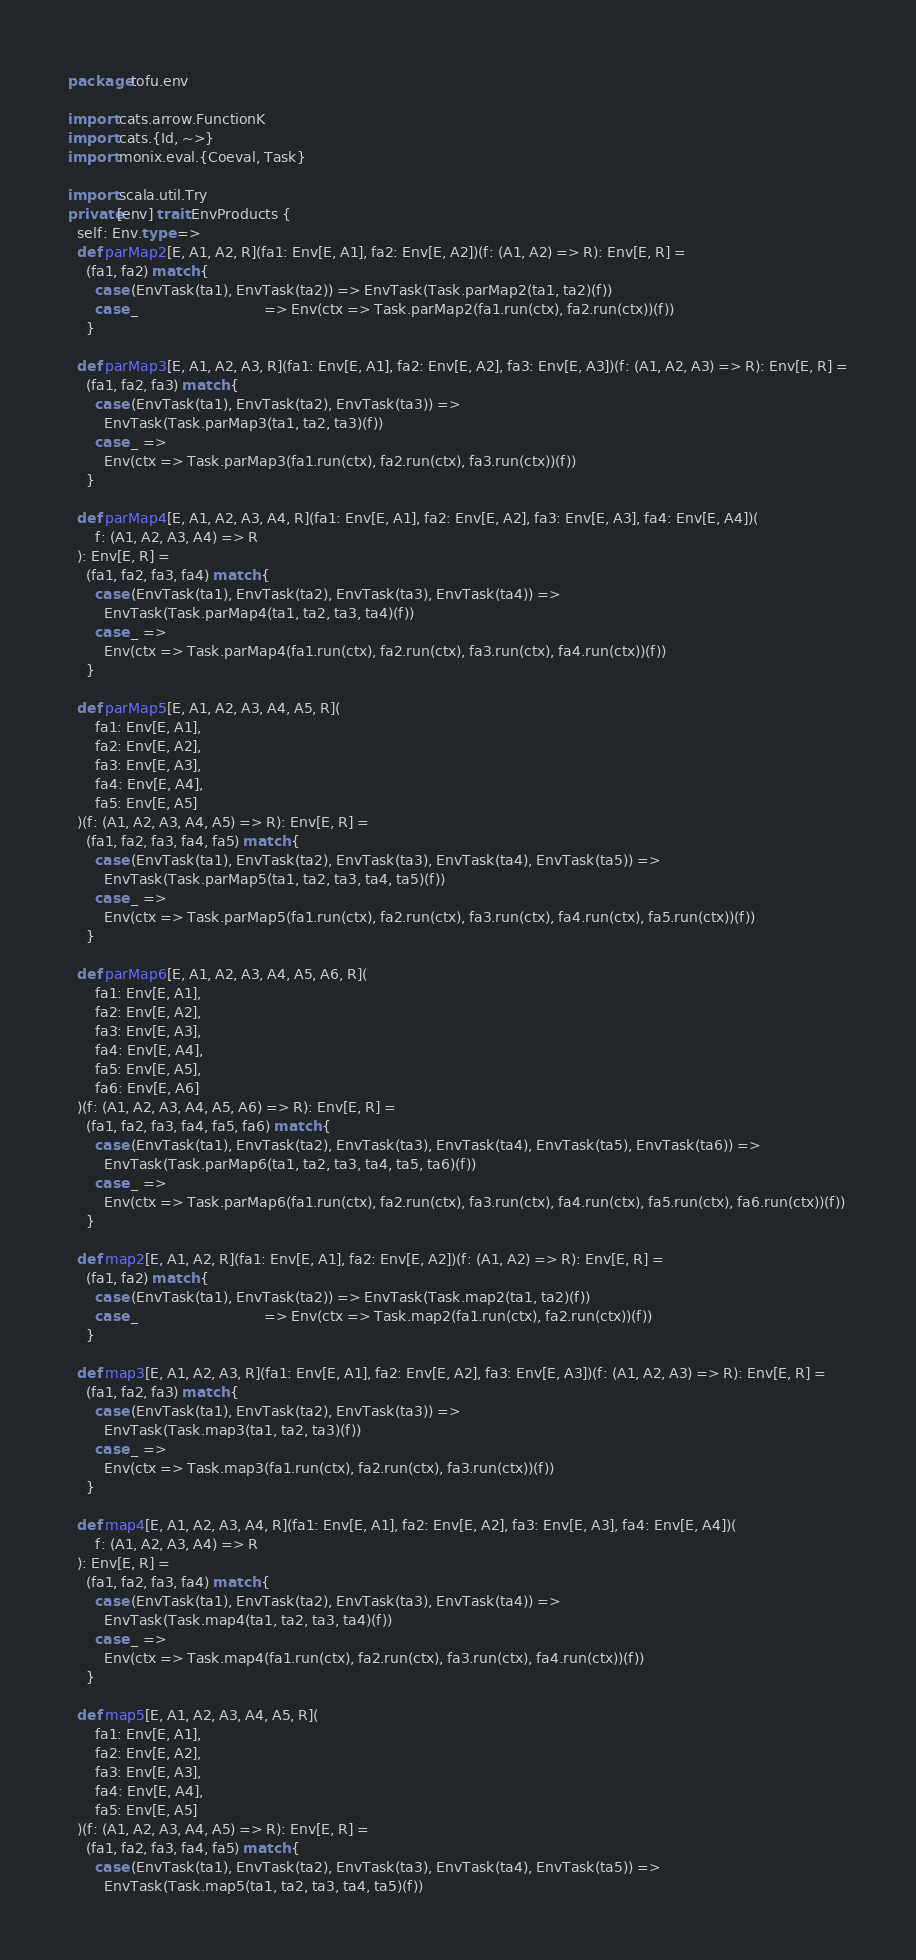Convert code to text. <code><loc_0><loc_0><loc_500><loc_500><_Scala_>package tofu.env

import cats.arrow.FunctionK
import cats.{Id, ~>}
import monix.eval.{Coeval, Task}

import scala.util.Try
private[env] trait EnvProducts {
  self: Env.type =>
  def parMap2[E, A1, A2, R](fa1: Env[E, A1], fa2: Env[E, A2])(f: (A1, A2) => R): Env[E, R] =
    (fa1, fa2) match {
      case (EnvTask(ta1), EnvTask(ta2)) => EnvTask(Task.parMap2(ta1, ta2)(f))
      case _                            => Env(ctx => Task.parMap2(fa1.run(ctx), fa2.run(ctx))(f))
    }

  def parMap3[E, A1, A2, A3, R](fa1: Env[E, A1], fa2: Env[E, A2], fa3: Env[E, A3])(f: (A1, A2, A3) => R): Env[E, R] =
    (fa1, fa2, fa3) match {
      case (EnvTask(ta1), EnvTask(ta2), EnvTask(ta3)) =>
        EnvTask(Task.parMap3(ta1, ta2, ta3)(f))
      case _ =>
        Env(ctx => Task.parMap3(fa1.run(ctx), fa2.run(ctx), fa3.run(ctx))(f))
    }

  def parMap4[E, A1, A2, A3, A4, R](fa1: Env[E, A1], fa2: Env[E, A2], fa3: Env[E, A3], fa4: Env[E, A4])(
      f: (A1, A2, A3, A4) => R
  ): Env[E, R] =
    (fa1, fa2, fa3, fa4) match {
      case (EnvTask(ta1), EnvTask(ta2), EnvTask(ta3), EnvTask(ta4)) =>
        EnvTask(Task.parMap4(ta1, ta2, ta3, ta4)(f))
      case _ =>
        Env(ctx => Task.parMap4(fa1.run(ctx), fa2.run(ctx), fa3.run(ctx), fa4.run(ctx))(f))
    }

  def parMap5[E, A1, A2, A3, A4, A5, R](
      fa1: Env[E, A1],
      fa2: Env[E, A2],
      fa3: Env[E, A3],
      fa4: Env[E, A4],
      fa5: Env[E, A5]
  )(f: (A1, A2, A3, A4, A5) => R): Env[E, R] =
    (fa1, fa2, fa3, fa4, fa5) match {
      case (EnvTask(ta1), EnvTask(ta2), EnvTask(ta3), EnvTask(ta4), EnvTask(ta5)) =>
        EnvTask(Task.parMap5(ta1, ta2, ta3, ta4, ta5)(f))
      case _ =>
        Env(ctx => Task.parMap5(fa1.run(ctx), fa2.run(ctx), fa3.run(ctx), fa4.run(ctx), fa5.run(ctx))(f))
    }

  def parMap6[E, A1, A2, A3, A4, A5, A6, R](
      fa1: Env[E, A1],
      fa2: Env[E, A2],
      fa3: Env[E, A3],
      fa4: Env[E, A4],
      fa5: Env[E, A5],
      fa6: Env[E, A6]
  )(f: (A1, A2, A3, A4, A5, A6) => R): Env[E, R] =
    (fa1, fa2, fa3, fa4, fa5, fa6) match {
      case (EnvTask(ta1), EnvTask(ta2), EnvTask(ta3), EnvTask(ta4), EnvTask(ta5), EnvTask(ta6)) =>
        EnvTask(Task.parMap6(ta1, ta2, ta3, ta4, ta5, ta6)(f))
      case _ =>
        Env(ctx => Task.parMap6(fa1.run(ctx), fa2.run(ctx), fa3.run(ctx), fa4.run(ctx), fa5.run(ctx), fa6.run(ctx))(f))
    }

  def map2[E, A1, A2, R](fa1: Env[E, A1], fa2: Env[E, A2])(f: (A1, A2) => R): Env[E, R] =
    (fa1, fa2) match {
      case (EnvTask(ta1), EnvTask(ta2)) => EnvTask(Task.map2(ta1, ta2)(f))
      case _                            => Env(ctx => Task.map2(fa1.run(ctx), fa2.run(ctx))(f))
    }

  def map3[E, A1, A2, A3, R](fa1: Env[E, A1], fa2: Env[E, A2], fa3: Env[E, A3])(f: (A1, A2, A3) => R): Env[E, R] =
    (fa1, fa2, fa3) match {
      case (EnvTask(ta1), EnvTask(ta2), EnvTask(ta3)) =>
        EnvTask(Task.map3(ta1, ta2, ta3)(f))
      case _ =>
        Env(ctx => Task.map3(fa1.run(ctx), fa2.run(ctx), fa3.run(ctx))(f))
    }

  def map4[E, A1, A2, A3, A4, R](fa1: Env[E, A1], fa2: Env[E, A2], fa3: Env[E, A3], fa4: Env[E, A4])(
      f: (A1, A2, A3, A4) => R
  ): Env[E, R] =
    (fa1, fa2, fa3, fa4) match {
      case (EnvTask(ta1), EnvTask(ta2), EnvTask(ta3), EnvTask(ta4)) =>
        EnvTask(Task.map4(ta1, ta2, ta3, ta4)(f))
      case _ =>
        Env(ctx => Task.map4(fa1.run(ctx), fa2.run(ctx), fa3.run(ctx), fa4.run(ctx))(f))
    }

  def map5[E, A1, A2, A3, A4, A5, R](
      fa1: Env[E, A1],
      fa2: Env[E, A2],
      fa3: Env[E, A3],
      fa4: Env[E, A4],
      fa5: Env[E, A5]
  )(f: (A1, A2, A3, A4, A5) => R): Env[E, R] =
    (fa1, fa2, fa3, fa4, fa5) match {
      case (EnvTask(ta1), EnvTask(ta2), EnvTask(ta3), EnvTask(ta4), EnvTask(ta5)) =>
        EnvTask(Task.map5(ta1, ta2, ta3, ta4, ta5)(f))</code> 